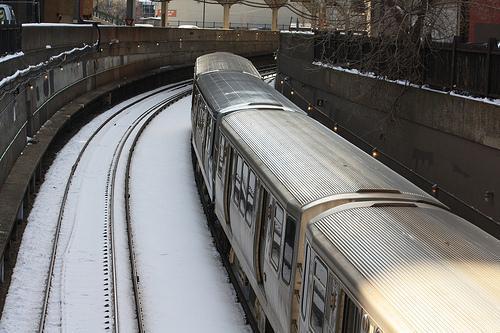How many train cars are visible?
Give a very brief answer. 4. 